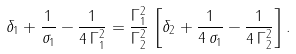Convert formula to latex. <formula><loc_0><loc_0><loc_500><loc_500>\delta _ { 1 } + \frac { 1 } { \sigma _ { 1 } } - \frac { 1 } { 4 \, \Gamma _ { 1 } ^ { 2 } } = \frac { \Gamma _ { 1 } ^ { 2 } } { \Gamma _ { 2 } ^ { 2 } } \, \left [ \delta _ { 2 } + \frac { 1 } { 4 \, \sigma _ { 1 } } - \frac { 1 } { 4 \, \Gamma _ { 2 } ^ { 2 } } \right ] .</formula> 